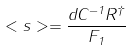<formula> <loc_0><loc_0><loc_500><loc_500>< s > = \frac { { d } C ^ { - 1 } { R } ^ { \dag } } { F _ { 1 } }</formula> 